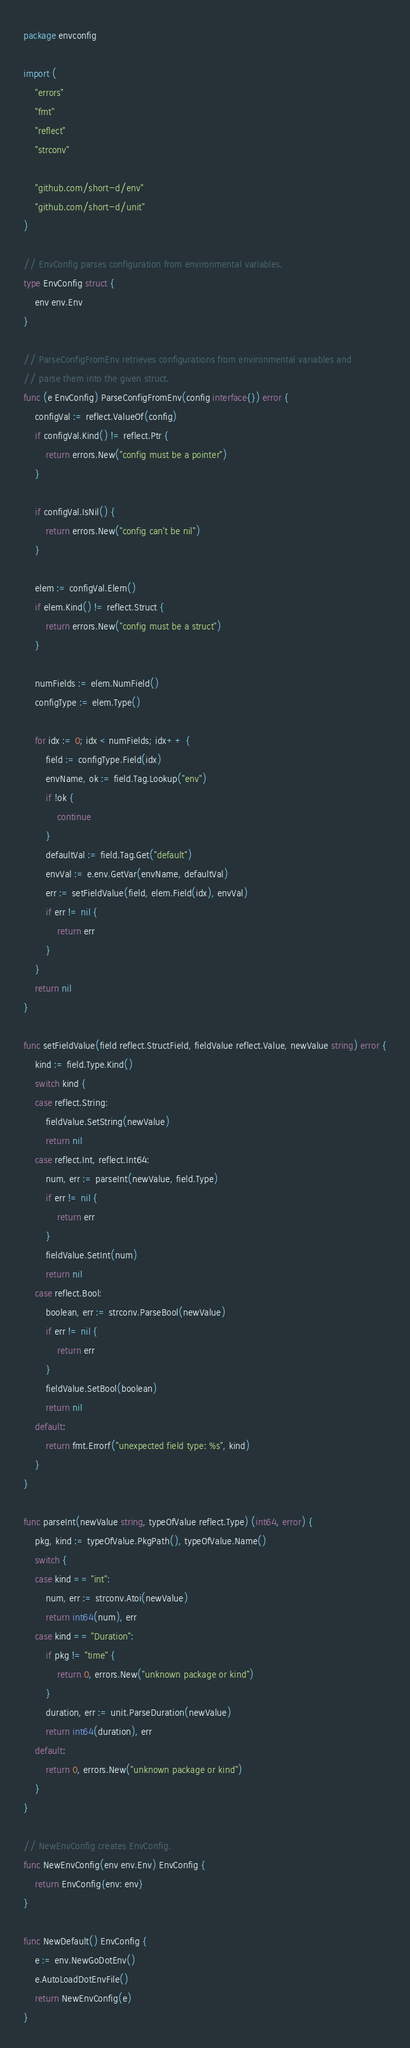<code> <loc_0><loc_0><loc_500><loc_500><_Go_>package envconfig

import (
	"errors"
	"fmt"
	"reflect"
	"strconv"

	"github.com/short-d/env"
	"github.com/short-d/unit"
)

// EnvConfig parses configuration from environmental variables.
type EnvConfig struct {
	env env.Env
}

// ParseConfigFromEnv retrieves configurations from environmental variables and
// parse them into the given struct.
func (e EnvConfig) ParseConfigFromEnv(config interface{}) error {
	configVal := reflect.ValueOf(config)
	if configVal.Kind() != reflect.Ptr {
		return errors.New("config must be a pointer")
	}

	if configVal.IsNil() {
		return errors.New("config can't be nil")
	}

	elem := configVal.Elem()
	if elem.Kind() != reflect.Struct {
		return errors.New("config must be a struct")
	}

	numFields := elem.NumField()
	configType := elem.Type()

	for idx := 0; idx < numFields; idx++ {
		field := configType.Field(idx)
		envName, ok := field.Tag.Lookup("env")
		if !ok {
			continue
		}
		defaultVal := field.Tag.Get("default")
		envVal := e.env.GetVar(envName, defaultVal)
		err := setFieldValue(field, elem.Field(idx), envVal)
		if err != nil {
			return err
		}
	}
	return nil
}

func setFieldValue(field reflect.StructField, fieldValue reflect.Value, newValue string) error {
	kind := field.Type.Kind()
	switch kind {
	case reflect.String:
		fieldValue.SetString(newValue)
		return nil
	case reflect.Int, reflect.Int64:
		num, err := parseInt(newValue, field.Type)
		if err != nil {
			return err
		}
		fieldValue.SetInt(num)
		return nil
	case reflect.Bool:
		boolean, err := strconv.ParseBool(newValue)
		if err != nil {
			return err
		}
		fieldValue.SetBool(boolean)
		return nil
	default:
		return fmt.Errorf("unexpected field type: %s", kind)
	}
}

func parseInt(newValue string, typeOfValue reflect.Type) (int64, error) {
	pkg, kind := typeOfValue.PkgPath(), typeOfValue.Name()
	switch {
	case kind == "int":
		num, err := strconv.Atoi(newValue)
		return int64(num), err
	case kind == "Duration":
		if pkg != "time" {
			return 0, errors.New("unknown package or kind")
		}
		duration, err := unit.ParseDuration(newValue)
		return int64(duration), err
	default:
		return 0, errors.New("unknown package or kind")
	}
}

// NewEnvConfig creates EnvConfig.
func NewEnvConfig(env env.Env) EnvConfig {
	return EnvConfig{env: env}
}

func NewDefault() EnvConfig {
	e := env.NewGoDotEnv()
	e.AutoLoadDotEnvFile()
	return NewEnvConfig(e)
}</code> 